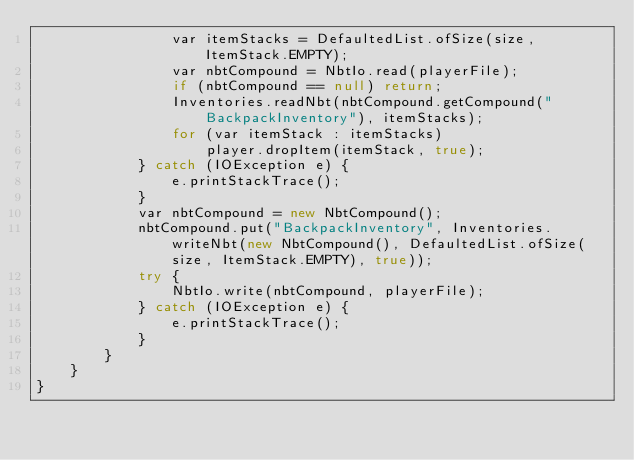<code> <loc_0><loc_0><loc_500><loc_500><_Java_>                var itemStacks = DefaultedList.ofSize(size, ItemStack.EMPTY);
                var nbtCompound = NbtIo.read(playerFile);
                if (nbtCompound == null) return;
                Inventories.readNbt(nbtCompound.getCompound("BackpackInventory"), itemStacks);
                for (var itemStack : itemStacks)
                    player.dropItem(itemStack, true);
            } catch (IOException e) {
                e.printStackTrace();
            }
            var nbtCompound = new NbtCompound();
            nbtCompound.put("BackpackInventory", Inventories.writeNbt(new NbtCompound(), DefaultedList.ofSize(size, ItemStack.EMPTY), true));
            try {
                NbtIo.write(nbtCompound, playerFile);
            } catch (IOException e) {
                e.printStackTrace();
            }
        }
    }
}
</code> 